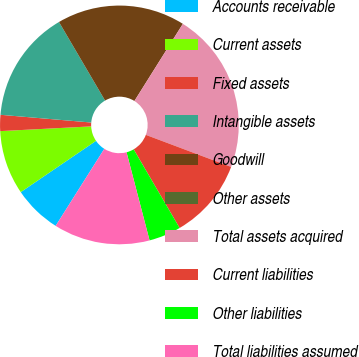Convert chart to OTSL. <chart><loc_0><loc_0><loc_500><loc_500><pie_chart><fcel>Accounts receivable<fcel>Current assets<fcel>Fixed assets<fcel>Intangible assets<fcel>Goodwill<fcel>Other assets<fcel>Total assets acquired<fcel>Current liabilities<fcel>Other liabilities<fcel>Total liabilities assumed<nl><fcel>6.52%<fcel>8.69%<fcel>2.18%<fcel>15.2%<fcel>17.37%<fcel>0.0%<fcel>21.8%<fcel>10.86%<fcel>4.35%<fcel>13.03%<nl></chart> 